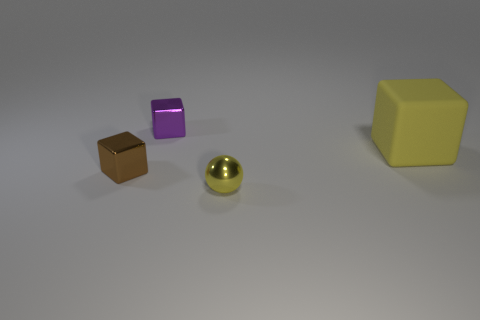What shape is the small purple thing?
Offer a terse response. Cube. What size is the cube on the right side of the metal thing that is in front of the small cube left of the purple thing?
Make the answer very short. Large. What number of other objects are there of the same shape as the yellow metal object?
Make the answer very short. 0. There is a metal object behind the large yellow matte block; does it have the same shape as the yellow thing left of the matte cube?
Give a very brief answer. No. How many blocks are either big red objects or small yellow shiny objects?
Your answer should be compact. 0. What material is the cube left of the block that is behind the yellow object that is behind the tiny brown shiny cube?
Your answer should be compact. Metal. How many other objects are there of the same size as the matte object?
Keep it short and to the point. 0. The block that is the same color as the shiny sphere is what size?
Offer a terse response. Large. Is the number of tiny metal objects that are behind the large yellow matte cube greater than the number of tiny blue shiny things?
Make the answer very short. Yes. Are there any large matte things that have the same color as the tiny shiny ball?
Make the answer very short. Yes. 